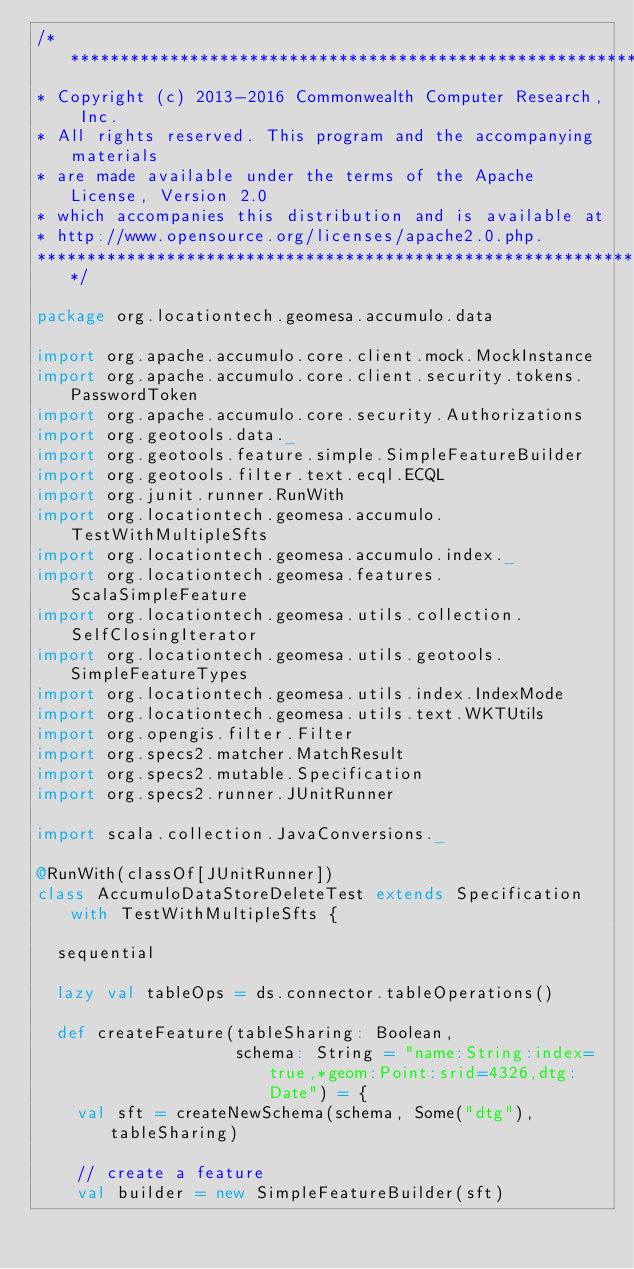<code> <loc_0><loc_0><loc_500><loc_500><_Scala_>/***********************************************************************
* Copyright (c) 2013-2016 Commonwealth Computer Research, Inc.
* All rights reserved. This program and the accompanying materials
* are made available under the terms of the Apache License, Version 2.0
* which accompanies this distribution and is available at
* http://www.opensource.org/licenses/apache2.0.php.
*************************************************************************/

package org.locationtech.geomesa.accumulo.data

import org.apache.accumulo.core.client.mock.MockInstance
import org.apache.accumulo.core.client.security.tokens.PasswordToken
import org.apache.accumulo.core.security.Authorizations
import org.geotools.data._
import org.geotools.feature.simple.SimpleFeatureBuilder
import org.geotools.filter.text.ecql.ECQL
import org.junit.runner.RunWith
import org.locationtech.geomesa.accumulo.TestWithMultipleSfts
import org.locationtech.geomesa.accumulo.index._
import org.locationtech.geomesa.features.ScalaSimpleFeature
import org.locationtech.geomesa.utils.collection.SelfClosingIterator
import org.locationtech.geomesa.utils.geotools.SimpleFeatureTypes
import org.locationtech.geomesa.utils.index.IndexMode
import org.locationtech.geomesa.utils.text.WKTUtils
import org.opengis.filter.Filter
import org.specs2.matcher.MatchResult
import org.specs2.mutable.Specification
import org.specs2.runner.JUnitRunner

import scala.collection.JavaConversions._

@RunWith(classOf[JUnitRunner])
class AccumuloDataStoreDeleteTest extends Specification with TestWithMultipleSfts {

  sequential

  lazy val tableOps = ds.connector.tableOperations()

  def createFeature(tableSharing: Boolean,
                    schema: String = "name:String:index=true,*geom:Point:srid=4326,dtg:Date") = {
    val sft = createNewSchema(schema, Some("dtg"), tableSharing)

    // create a feature
    val builder = new SimpleFeatureBuilder(sft)</code> 